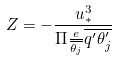Convert formula to latex. <formula><loc_0><loc_0><loc_500><loc_500>Z = - \frac { u _ { * } ^ { 3 } } { \Pi \frac { e } { \overline { \theta _ { j } } } \overline { q ^ { \prime } \theta _ { j } ^ { \prime } } }</formula> 